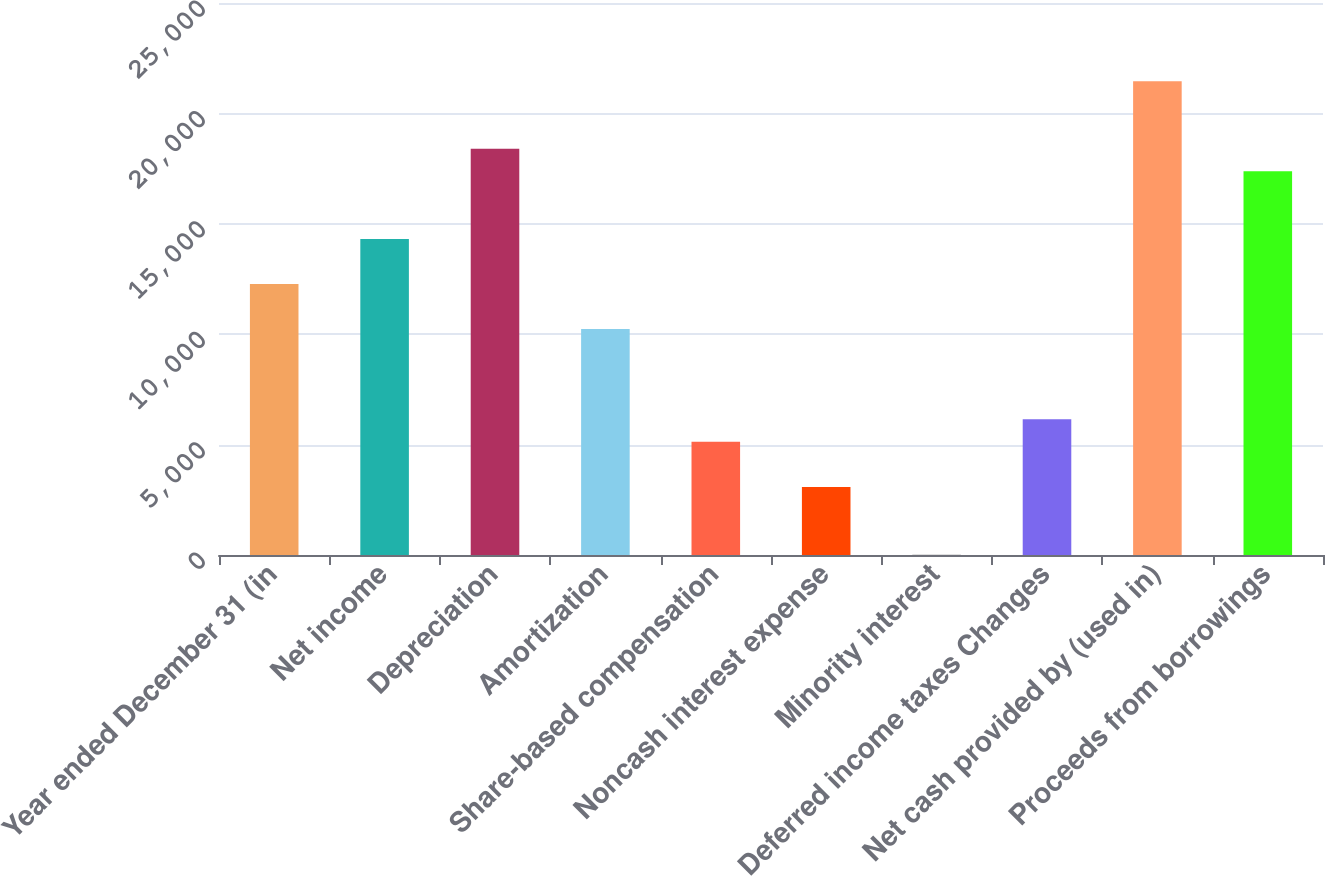Convert chart. <chart><loc_0><loc_0><loc_500><loc_500><bar_chart><fcel>Year ended December 31 (in<fcel>Net income<fcel>Depreciation<fcel>Amortization<fcel>Share-based compensation<fcel>Noncash interest expense<fcel>Minority interest<fcel>Deferred income taxes Changes<fcel>Net cash provided by (used in)<fcel>Proceeds from borrowings<nl><fcel>12272.8<fcel>14314.6<fcel>18398.2<fcel>10231<fcel>5126.5<fcel>3084.7<fcel>22<fcel>6147.4<fcel>21460.9<fcel>17377.3<nl></chart> 